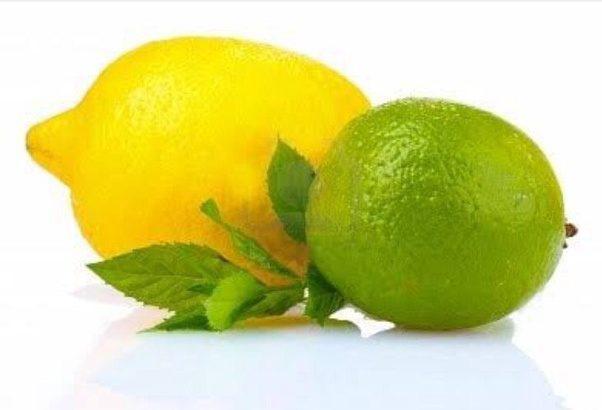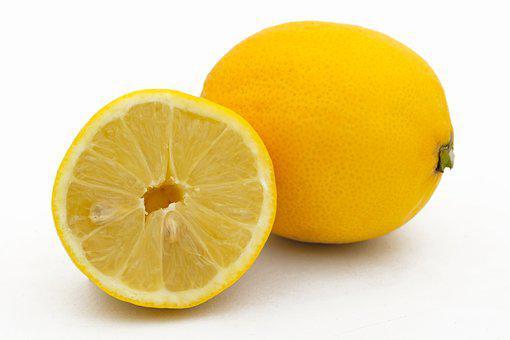The first image is the image on the left, the second image is the image on the right. Evaluate the accuracy of this statement regarding the images: "In at least one image there are at least four different types of citrus fruit.". Is it true? Answer yes or no. No. The first image is the image on the left, the second image is the image on the right. For the images shown, is this caption "The right image contains three lemons, one of which has been cut in half." true? Answer yes or no. No. 